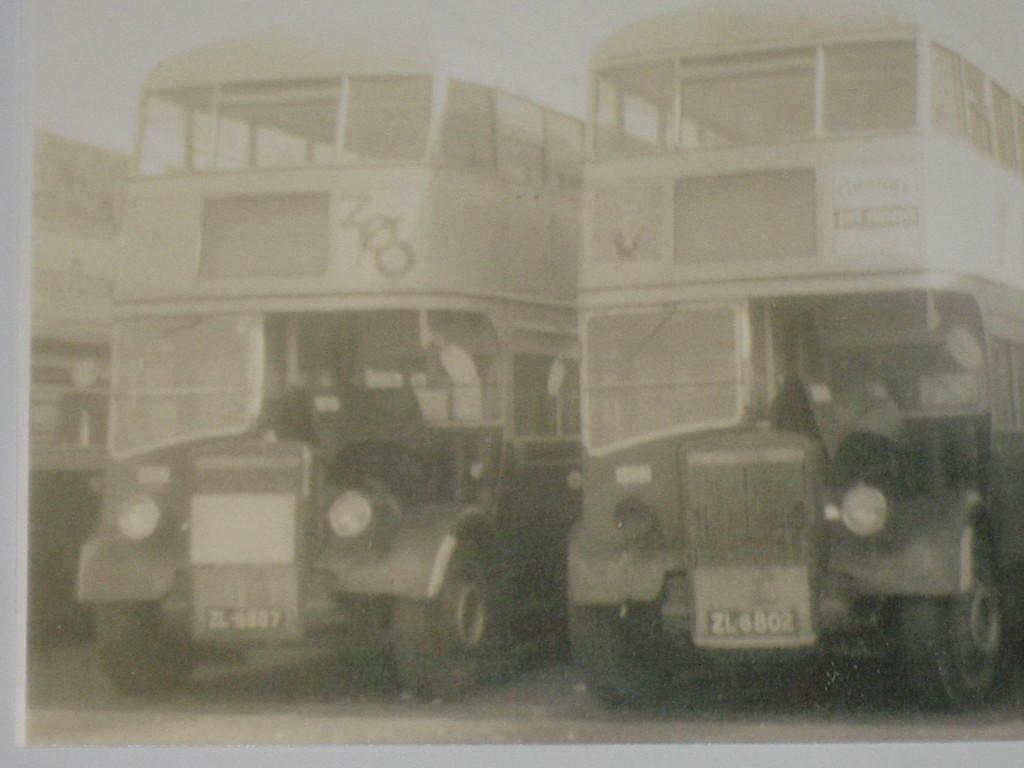What type of smell can be detected during the journey in the image? There is no image or journey present, so it is not possible to determine any smells associated with them. 